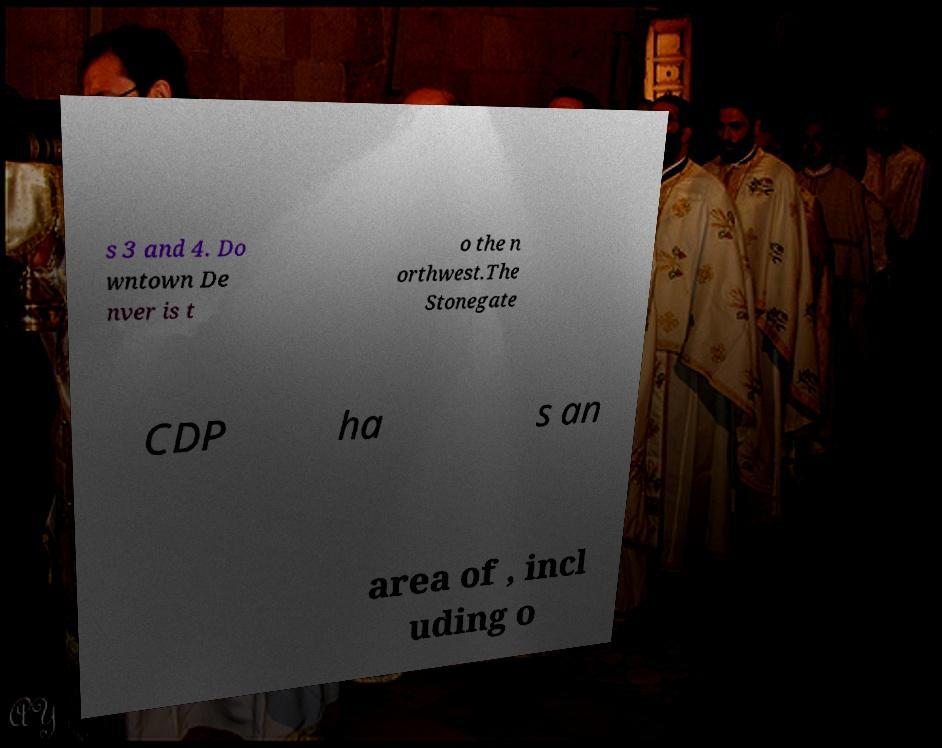Could you assist in decoding the text presented in this image and type it out clearly? s 3 and 4. Do wntown De nver is t o the n orthwest.The Stonegate CDP ha s an area of , incl uding o 